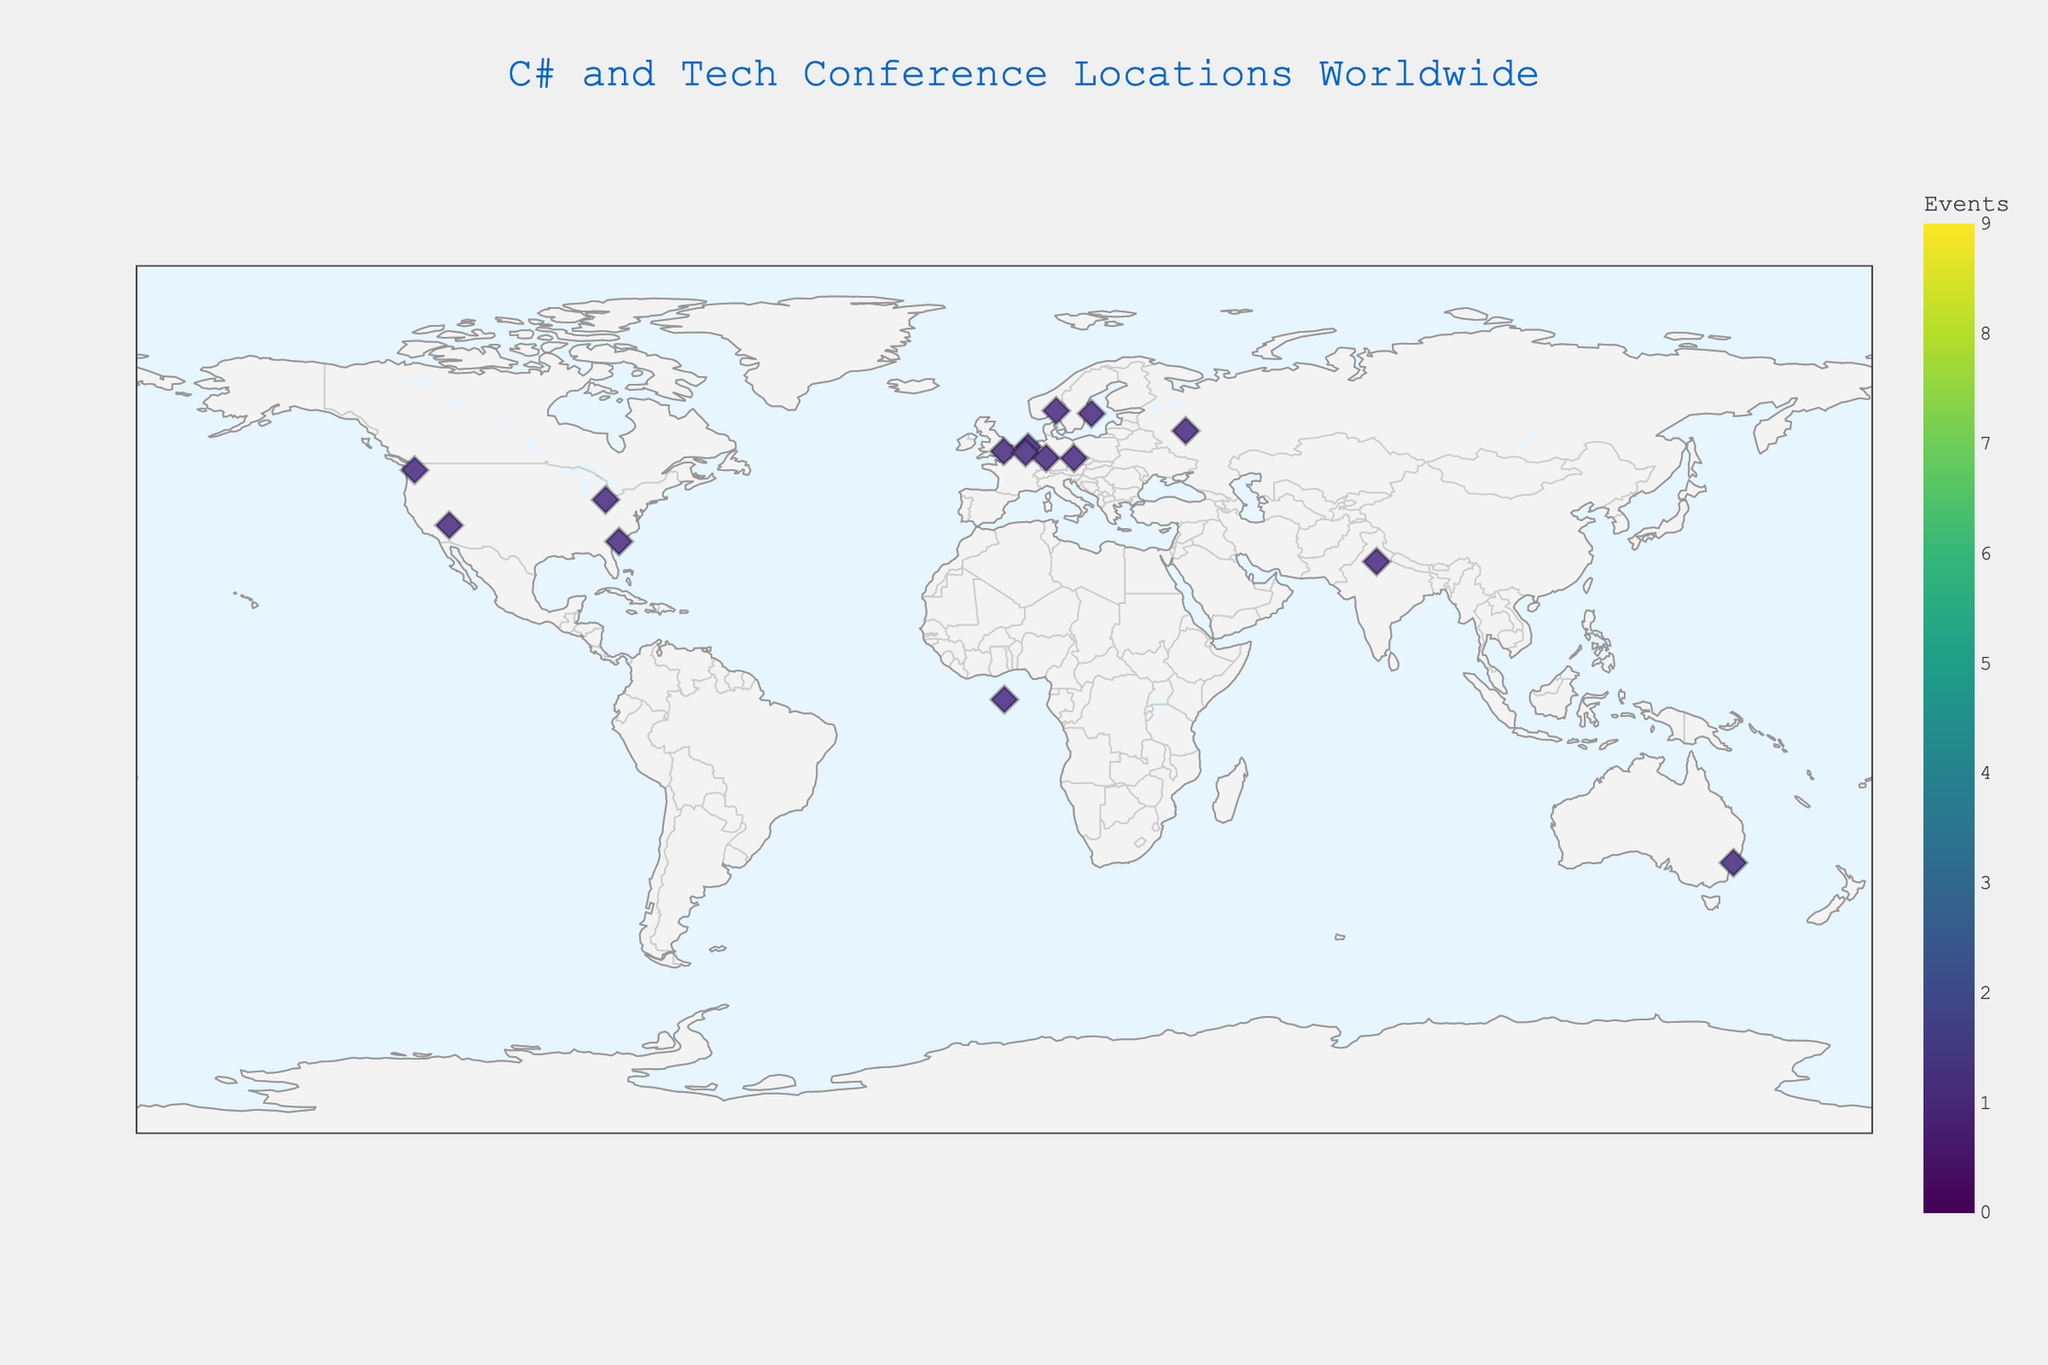What is the title of the plot? The title of the plot is written at the top center of the figure and is styled larger than other text elements. It reads 'C# and Tech Conference Locations Worldwide'.
Answer: C# and Tech Conference Locations Worldwide In which cities in the USA are the tech conferences located? The plot shows markers in several locations in the USA with hover information displaying city names. The cities are Seattle, Las Vegas, Charleston, and Sandusky.
Answer: Seattle, Las Vegas, Charleston, Sandusky Which event is located in Sydney, Australia? By looking at the figure and matching the latitude and longitude for Sydney, Australia, the event located here is "C# Developers Workshop".
Answer: C# Developers Workshop How many tech conferences are listed in Europe? To determine this, we look at the markers located in Europe and count them. The cities are Oslo, Amsterdam, London, Antwerp, Stockholm, Prague, and Frankfurt. Thus, there are 7 conferences in Europe.
Answer: 7 Which countries in Europe host major tech conferences? This can be determined by identifying the European marker locations and their corresponding countries. These countries are Norway, Netherlands, UK, Belgium, Sweden, Czech Republic, and Germany.
Answer: Norway, Netherlands, UK, Belgium, Sweden, Czech Republic, Germany What is the northernmost conference location and its event? Observing the map, the northernmost marker is in Oslo, Norway. The event held here is "NDC Oslo".
Answer: Oslo, NDC Oslo Are there more tech conferences in the USA or Europe? By counting the number of markers in the USA (4: Seattle, Las Vegas, Charleston, Sandusky) and Europe (7: Oslo, Amsterdam, London, Antwerp, Stockholm, Prague, Frankfurt), it is clear that Europe has more tech conferences than the USA.
Answer: Europe Which event is represented at the coordinates (59.9139, 10.7522)? These coordinates can be found by looking for the corresponding marker on the map in the figure. The event at these coordinates is "NDC Oslo".
Answer: NDC Oslo Which city in India hosts a C# workshop? By looking at the markers and their hover information for India, the city listed for a C# workshop is Delhi.
Answer: Delhi What is the event held in Amsterdam, Netherlands? Identifying Amsterdam's location on the map and checking its marker hover information, the event held in Amsterdam is "C# Developer Days".
Answer: C# Developer Days 